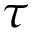<formula> <loc_0><loc_0><loc_500><loc_500>\tau</formula> 